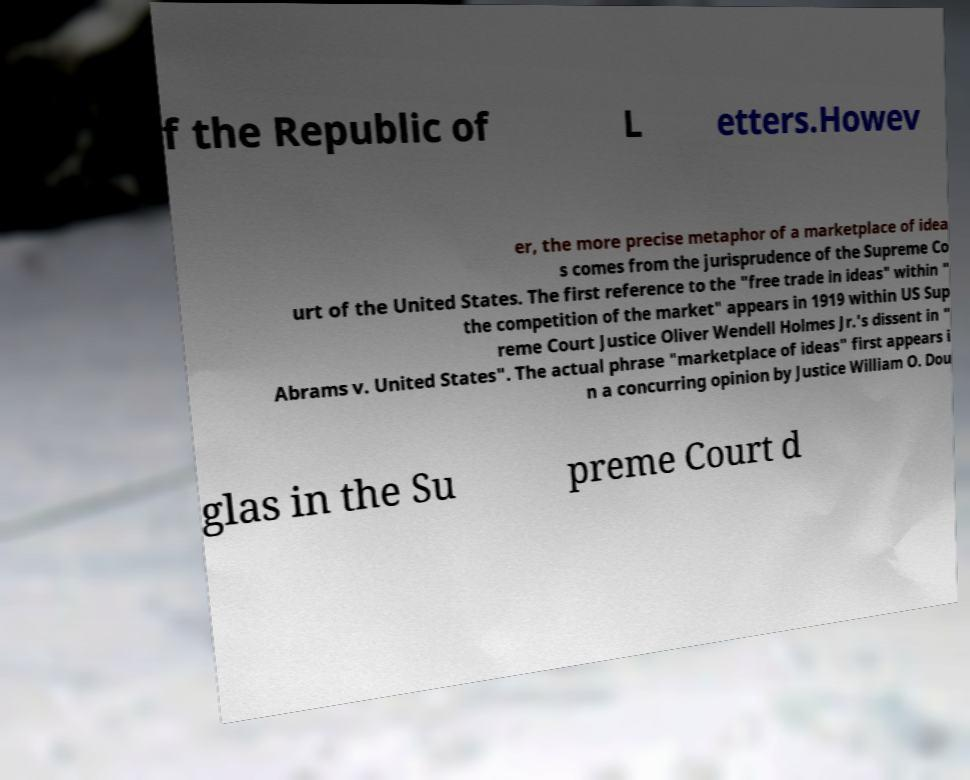Can you read and provide the text displayed in the image?This photo seems to have some interesting text. Can you extract and type it out for me? f the Republic of L etters.Howev er, the more precise metaphor of a marketplace of idea s comes from the jurisprudence of the Supreme Co urt of the United States. The first reference to the "free trade in ideas" within " the competition of the market" appears in 1919 within US Sup reme Court Justice Oliver Wendell Holmes Jr.'s dissent in " Abrams v. United States". The actual phrase "marketplace of ideas" first appears i n a concurring opinion by Justice William O. Dou glas in the Su preme Court d 